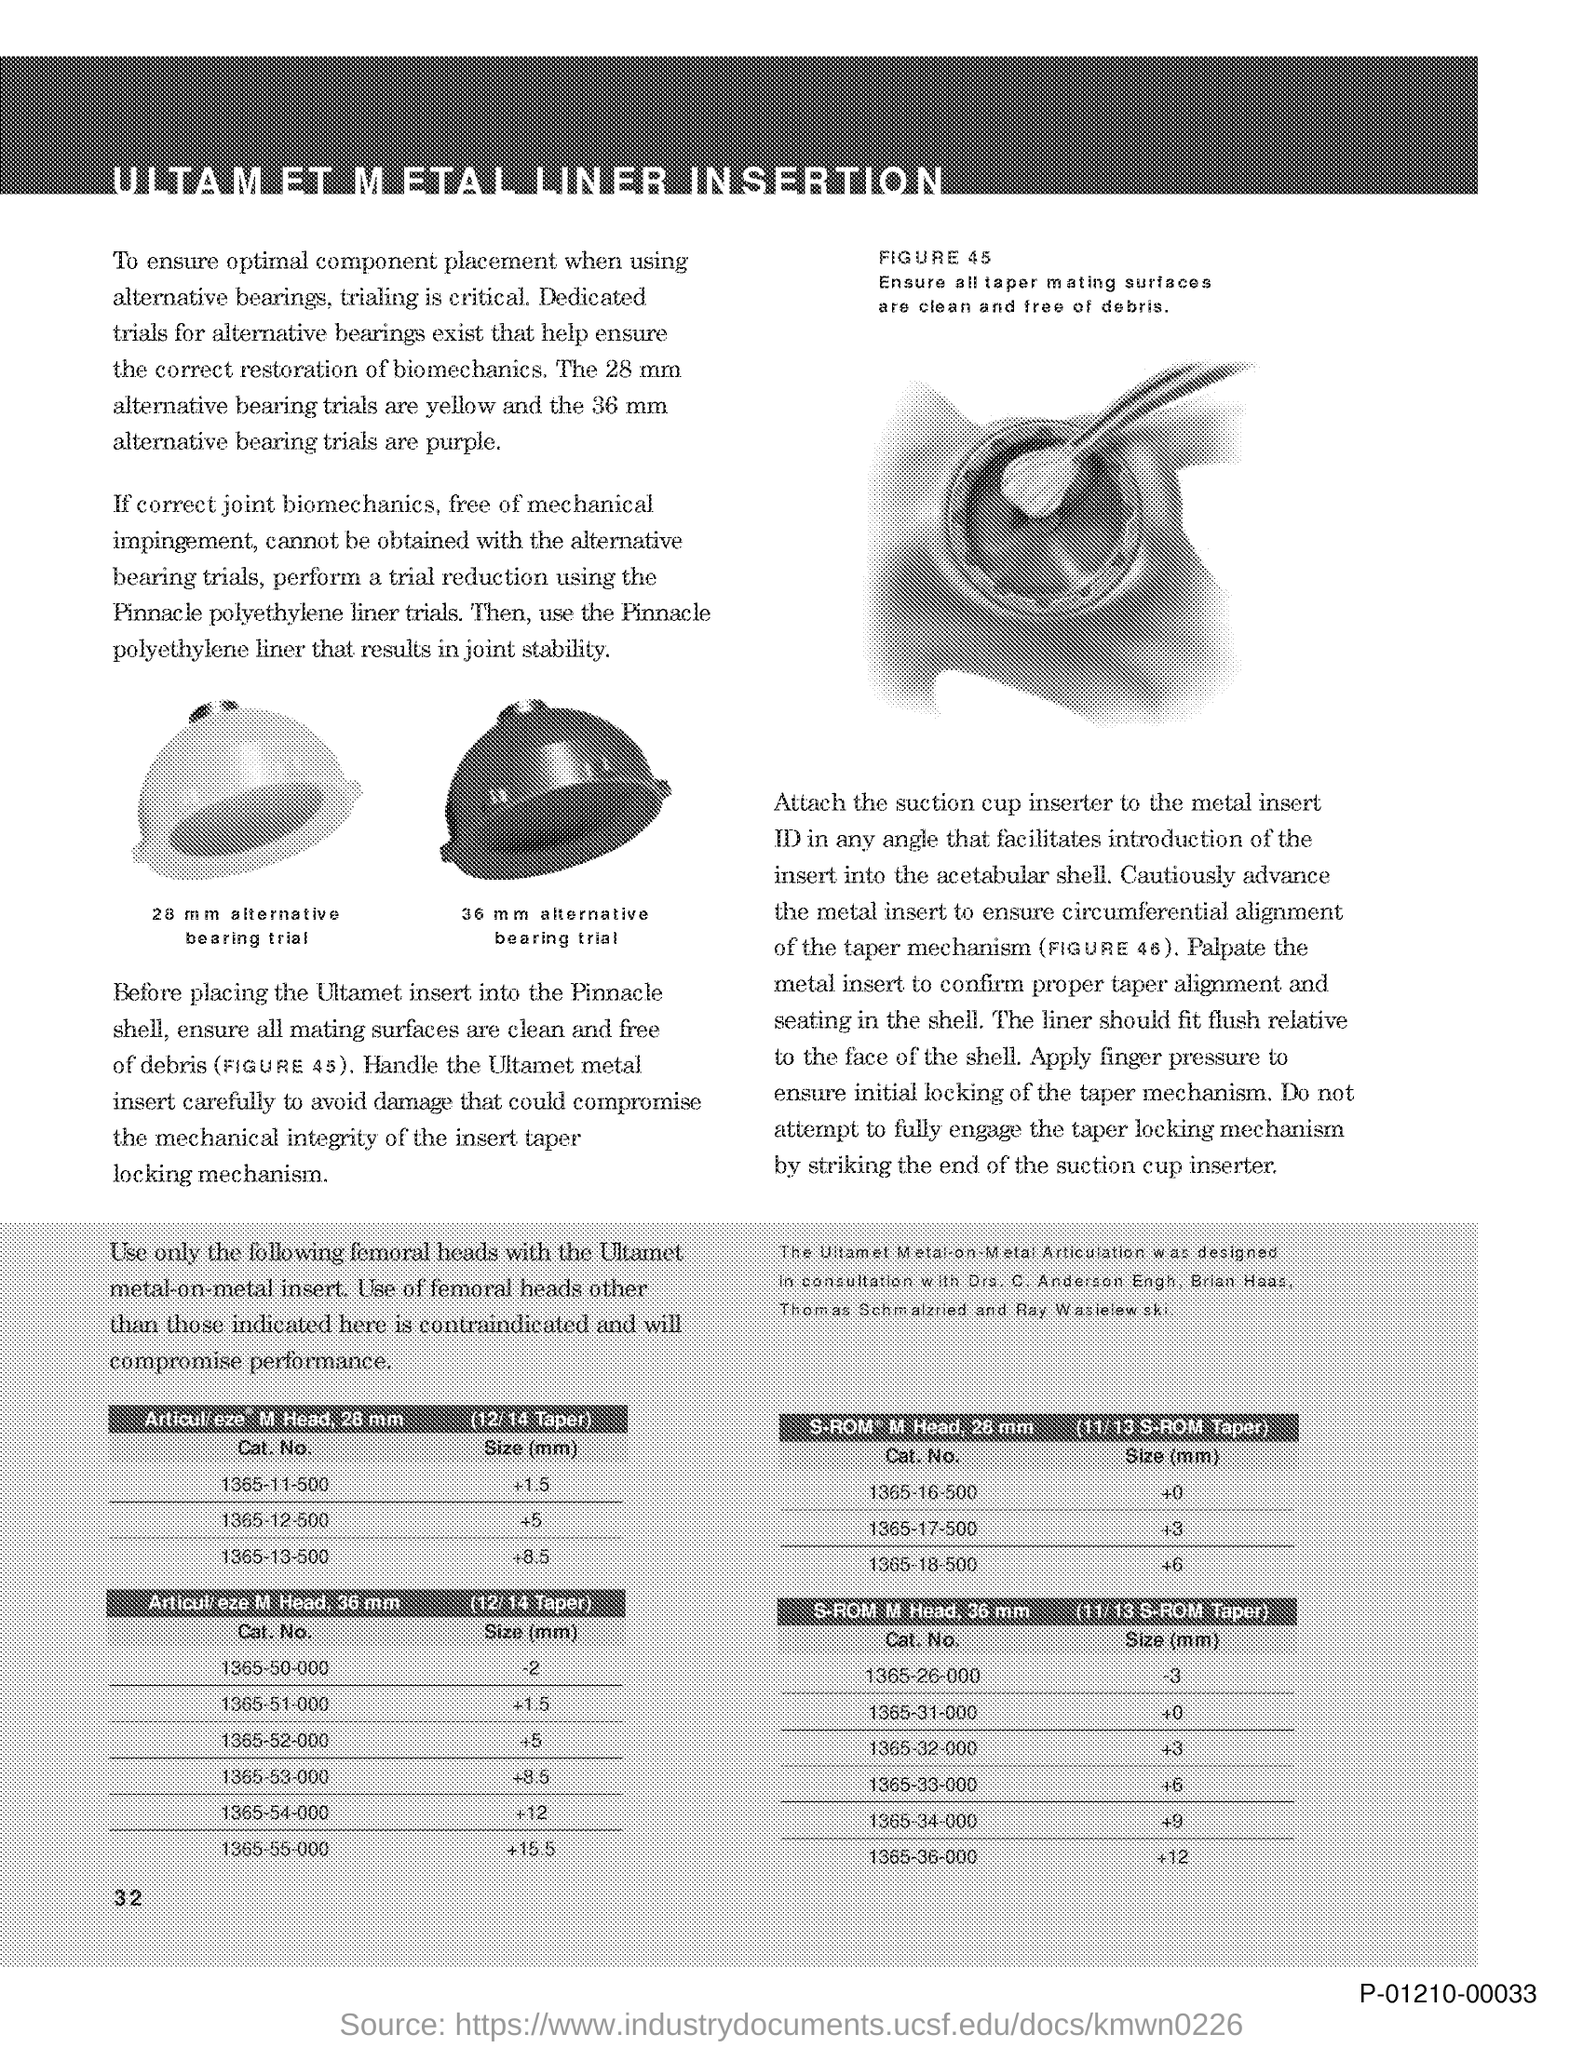What is the Page Number?
Your answer should be very brief. 32. 